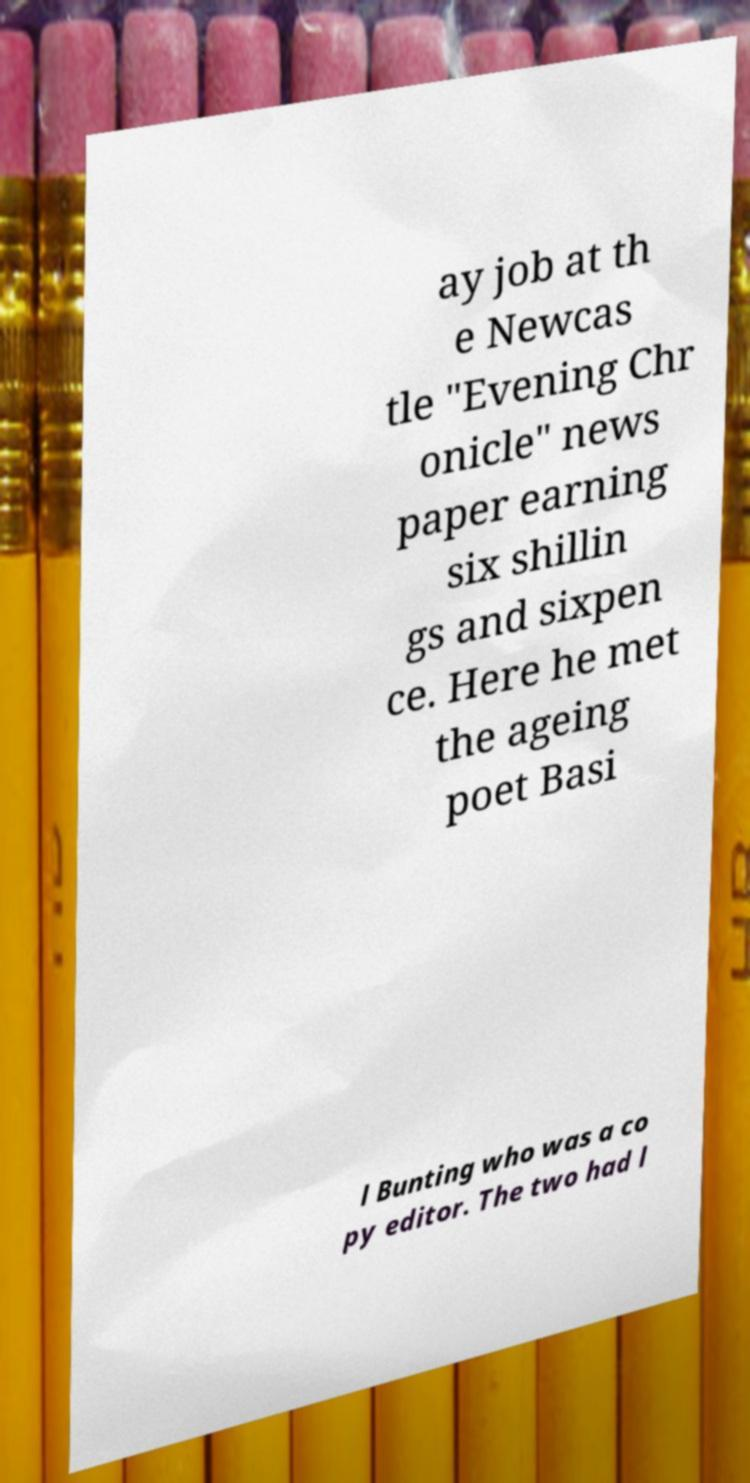Please identify and transcribe the text found in this image. ay job at th e Newcas tle "Evening Chr onicle" news paper earning six shillin gs and sixpen ce. Here he met the ageing poet Basi l Bunting who was a co py editor. The two had l 